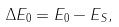<formula> <loc_0><loc_0><loc_500><loc_500>\Delta E _ { 0 } = E _ { 0 } - E _ { S } ,</formula> 